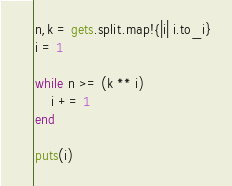Convert code to text. <code><loc_0><loc_0><loc_500><loc_500><_Ruby_>n,k = gets.split.map!{|i| i.to_i}
i = 1

while n >= (k ** i)
    i += 1 
end

puts(i)</code> 